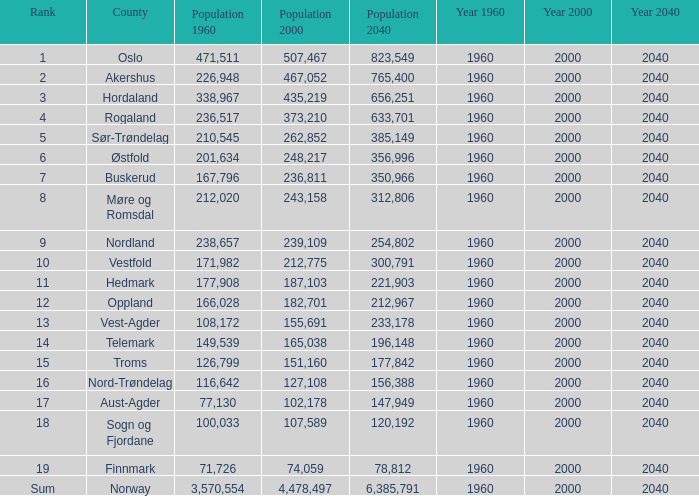For a county with a population of 467,052 in 2000 and 78,812 in 2040, what was its population in 1960? None. 